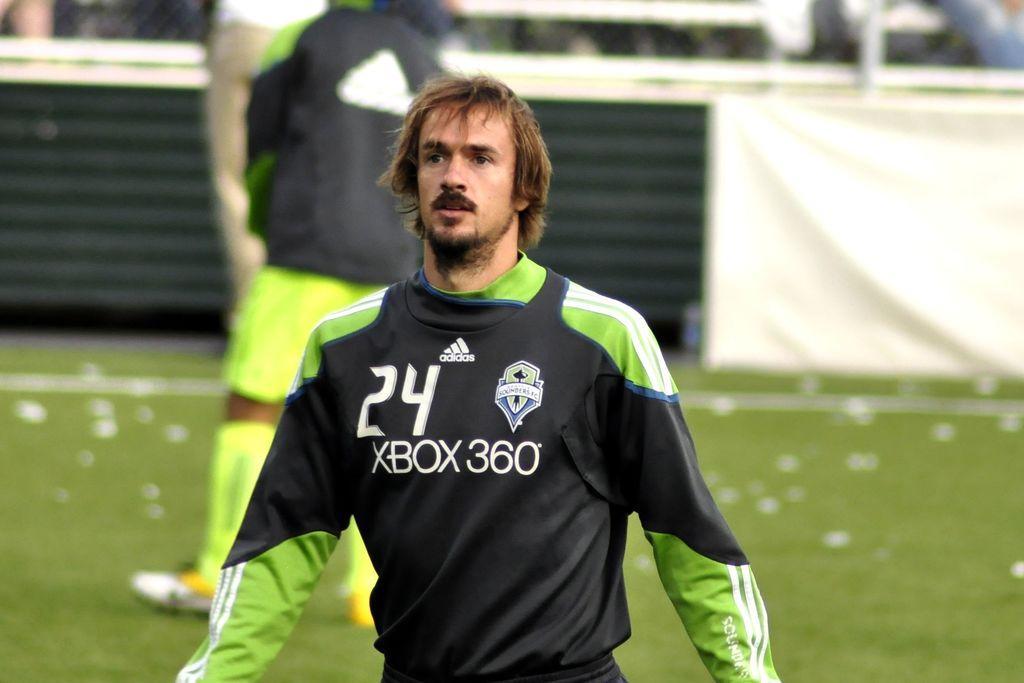Describe this image in one or two sentences. In this picture we can see a person, behind we can see few persons are standing in the grass. 